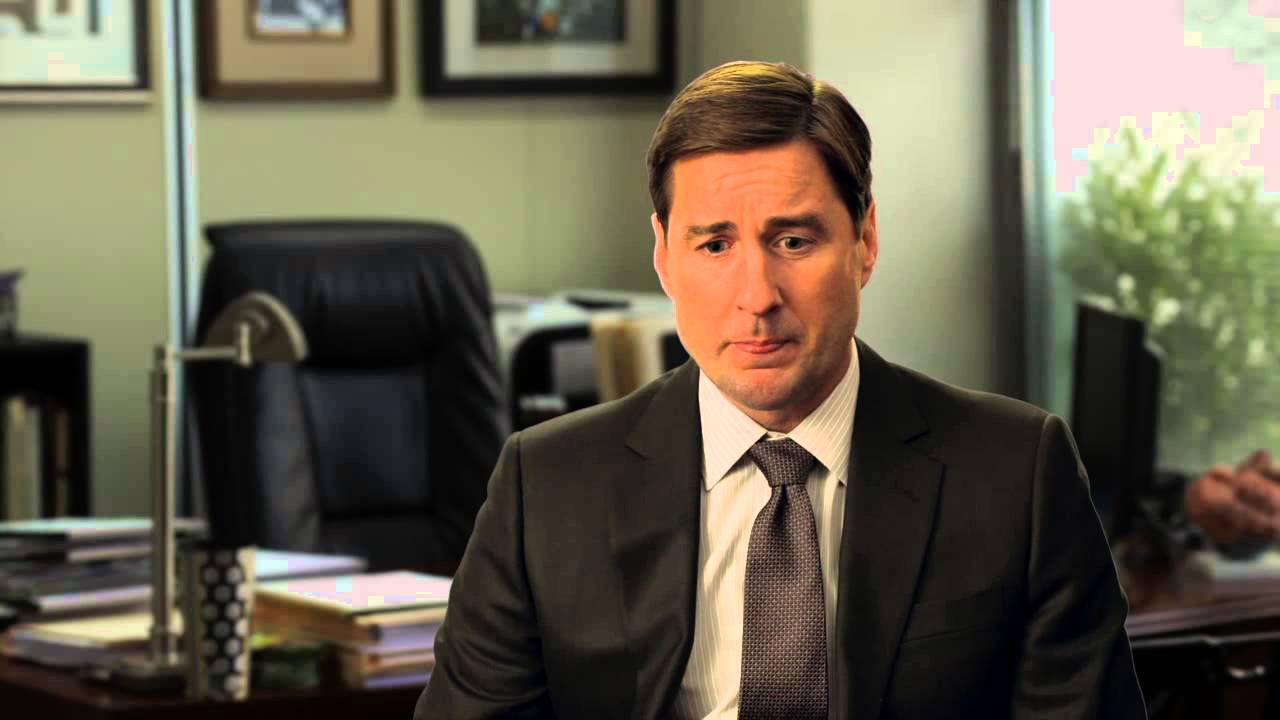Can you describe the office setting shown in this picture? The office setting is minimalist yet functional, with a focus on essentials like the desk and chair. There's a blend of personal and professional touches, evident from the documents scattered on the desk and the strategic placement of the plant, likely intended to bring a sense of calm and life to the workspace. 